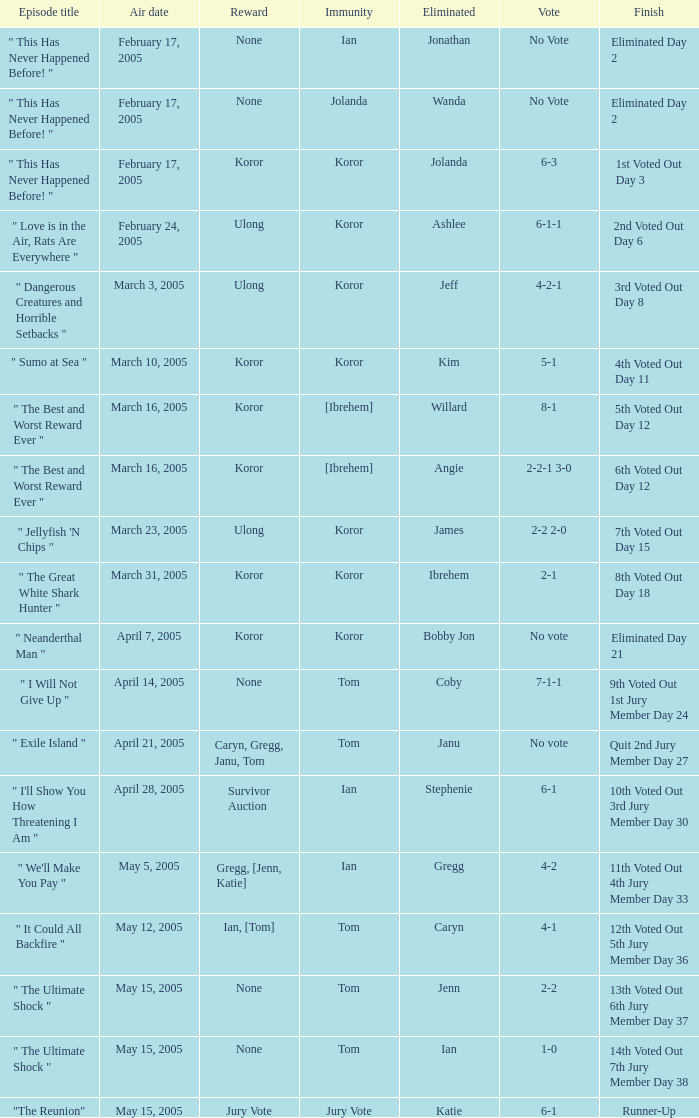Would you mind parsing the complete table? {'header': ['Episode title', 'Air date', 'Reward', 'Immunity', 'Eliminated', 'Vote', 'Finish'], 'rows': [['" This Has Never Happened Before! "', 'February 17, 2005', 'None', 'Ian', 'Jonathan', 'No Vote', 'Eliminated Day 2'], ['" This Has Never Happened Before! "', 'February 17, 2005', 'None', 'Jolanda', 'Wanda', 'No Vote', 'Eliminated Day 2'], ['" This Has Never Happened Before! "', 'February 17, 2005', 'Koror', 'Koror', 'Jolanda', '6-3', '1st Voted Out Day 3'], ['" Love is in the Air, Rats Are Everywhere "', 'February 24, 2005', 'Ulong', 'Koror', 'Ashlee', '6-1-1', '2nd Voted Out Day 6'], ['" Dangerous Creatures and Horrible Setbacks "', 'March 3, 2005', 'Ulong', 'Koror', 'Jeff', '4-2-1', '3rd Voted Out Day 8'], ['" Sumo at Sea "', 'March 10, 2005', 'Koror', 'Koror', 'Kim', '5-1', '4th Voted Out Day 11'], ['" The Best and Worst Reward Ever "', 'March 16, 2005', 'Koror', '[Ibrehem]', 'Willard', '8-1', '5th Voted Out Day 12'], ['" The Best and Worst Reward Ever "', 'March 16, 2005', 'Koror', '[Ibrehem]', 'Angie', '2-2-1 3-0', '6th Voted Out Day 12'], ['" Jellyfish \'N Chips "', 'March 23, 2005', 'Ulong', 'Koror', 'James', '2-2 2-0', '7th Voted Out Day 15'], ['" The Great White Shark Hunter "', 'March 31, 2005', 'Koror', 'Koror', 'Ibrehem', '2-1', '8th Voted Out Day 18'], ['" Neanderthal Man "', 'April 7, 2005', 'Koror', 'Koror', 'Bobby Jon', 'No vote', 'Eliminated Day 21'], ['" I Will Not Give Up "', 'April 14, 2005', 'None', 'Tom', 'Coby', '7-1-1', '9th Voted Out 1st Jury Member Day 24'], ['" Exile Island "', 'April 21, 2005', 'Caryn, Gregg, Janu, Tom', 'Tom', 'Janu', 'No vote', 'Quit 2nd Jury Member Day 27'], ['" I\'ll Show You How Threatening I Am "', 'April 28, 2005', 'Survivor Auction', 'Ian', 'Stephenie', '6-1', '10th Voted Out 3rd Jury Member Day 30'], ['" We\'ll Make You Pay "', 'May 5, 2005', 'Gregg, [Jenn, Katie]', 'Ian', 'Gregg', '4-2', '11th Voted Out 4th Jury Member Day 33'], ['" It Could All Backfire "', 'May 12, 2005', 'Ian, [Tom]', 'Tom', 'Caryn', '4-1', '12th Voted Out 5th Jury Member Day 36'], ['" The Ultimate Shock "', 'May 15, 2005', 'None', 'Tom', 'Jenn', '2-2', '13th Voted Out 6th Jury Member Day 37'], ['" The Ultimate Shock "', 'May 15, 2005', 'None', 'Tom', 'Ian', '1-0', '14th Voted Out 7th Jury Member Day 38'], ['"The Reunion"', 'May 15, 2005', 'Jury Vote', 'Jury Vote', 'Katie', '6-1', 'Runner-Up']]} How many votes were taken when the outcome was "6th voted out day 12"? 1.0. 